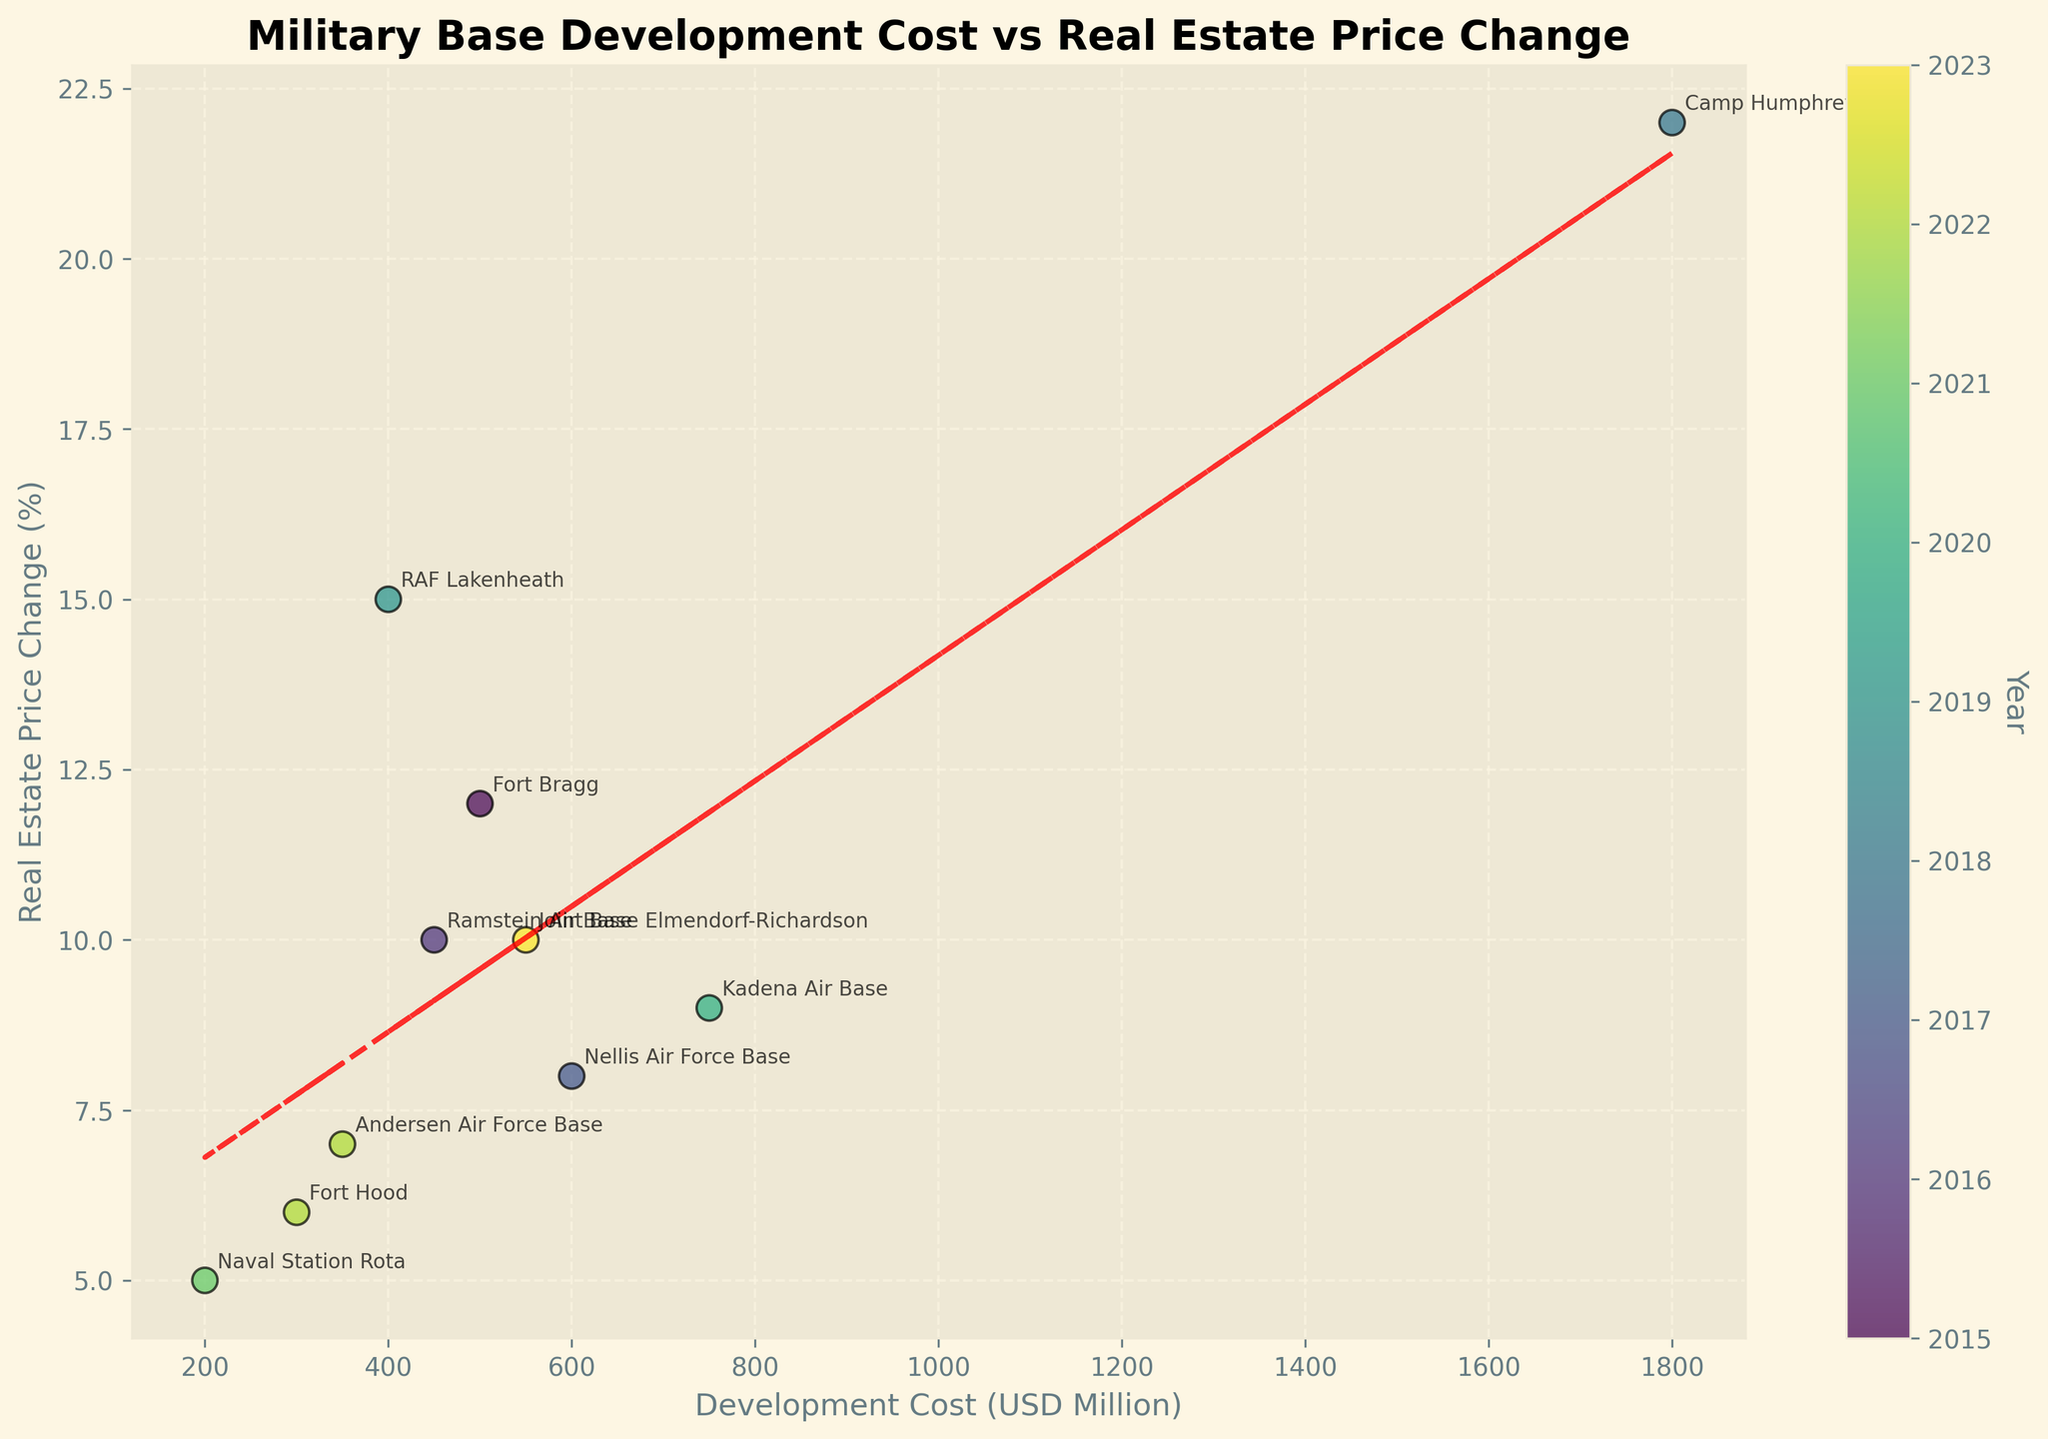What's the title of the plot? The title of the plot is located at the top of the figure in a bold font.
Answer: Military Base Development Cost vs Real Estate Price Change What is being shown on the x-axis? The x-axis label is at the bottom of the plot and typically provides the information being shown along the horizontal axis.
Answer: Development Cost (USD Million) Which military base had the highest real estate price change? Look for the data point with the highest y-axis value and read the annotated military base name next to it.
Answer: Camp Humphreys What's the color gradient used in the scatter plot? Notice the color indicates the year, highlighted by a gradient from older to more recent years.
Answer: Viridis What is the slope of the trend line? The slope of the trend line can be estimated from the red dashed line. The code provides a linear fit which is roughly the coefficient of the line equation y = mx + c.
Answer: 0.0071 How many military bases are depicted in the scatter plot? Count the number of data points (scatter marks) annotated with military base names in the plot.
Answer: 10 Which year shows the most significant jump in development cost compared to the previous years? Look for the largest increase in color gradient steps along the x-axis that is explicitly marked by each year.
Answer: 2018 Compare the real estate price change for the two bases in the United States with the closest development cost. Locate data points for the United States with comparable x-axis values and compare their y-values.
Answer: Las Vegas has 8%, Killeen has 6% What pattern does the trend line indicate about the relationship between development cost and real estate price change? Examine the direction and slope of the trend line to explain the overall trend found in the data.
Answer: Positive relationship Which country’s military base experienced the lowest increase in local real estate prices? Identify the point nearest the bottom of the y-axis and read the corresponding annotation.
Answer: Spain 